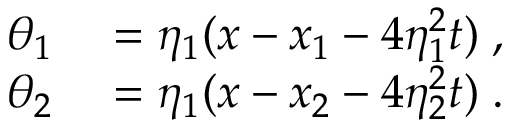Convert formula to latex. <formula><loc_0><loc_0><loc_500><loc_500>\begin{array} { r l } { \theta _ { 1 } } & = \eta _ { 1 } ( x - x _ { 1 } - 4 \eta _ { 1 } ^ { 2 } t ) \, , } \\ { \theta _ { 2 } } & = \eta _ { 1 } ( x - x _ { 2 } - 4 \eta _ { 2 } ^ { 2 } t ) \, . } \end{array}</formula> 